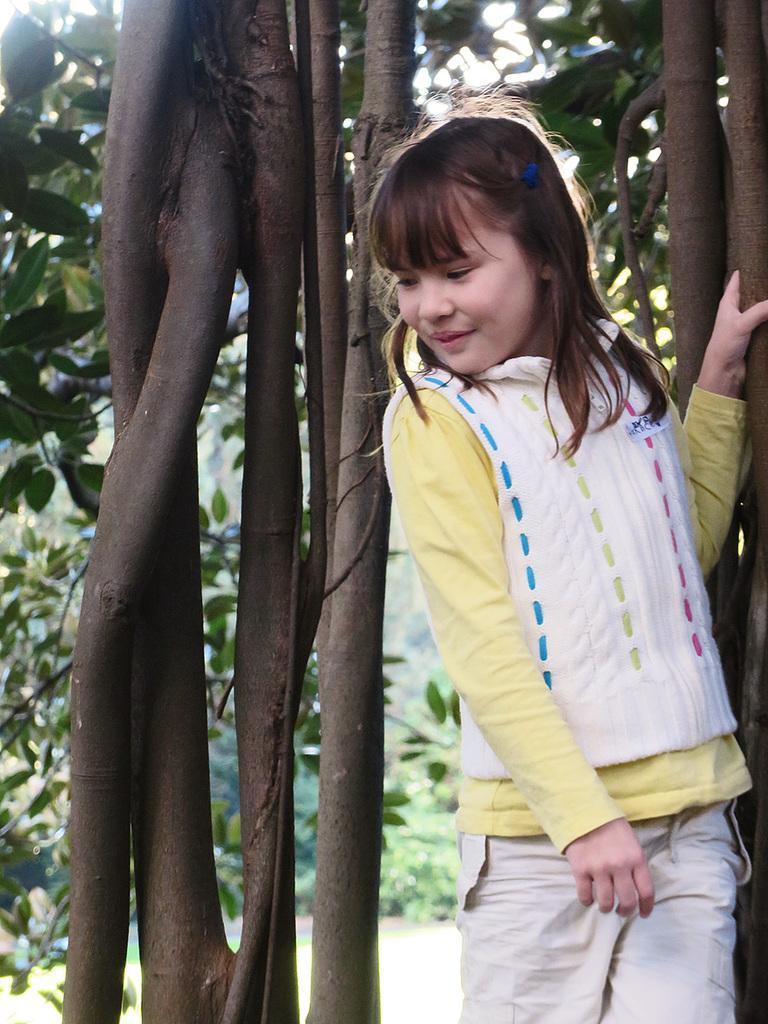How would you summarize this image in a sentence or two? In the foreground of this image, there is a girl standing on the right. Behind her, there is a tree. In the background, there is greenery. 